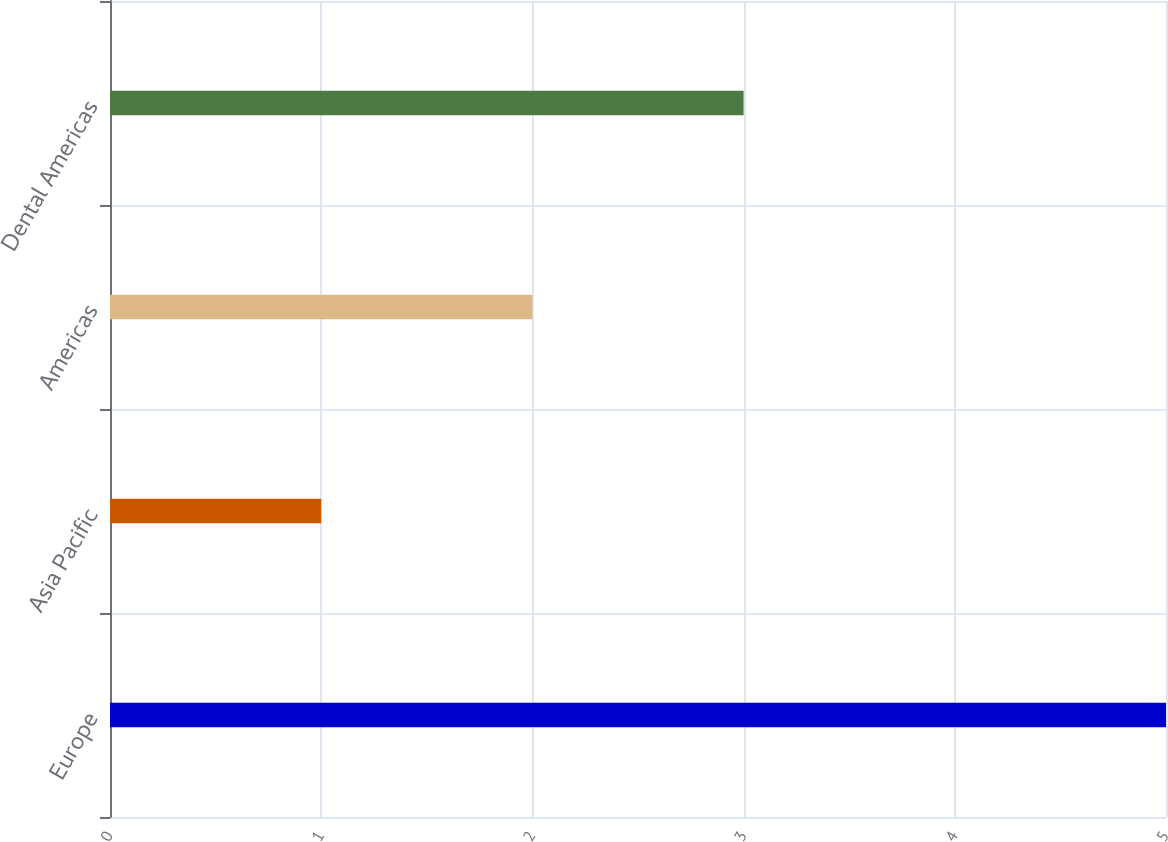Convert chart to OTSL. <chart><loc_0><loc_0><loc_500><loc_500><bar_chart><fcel>Europe<fcel>Asia Pacific<fcel>Americas<fcel>Dental Americas<nl><fcel>5<fcel>1<fcel>2<fcel>3<nl></chart> 